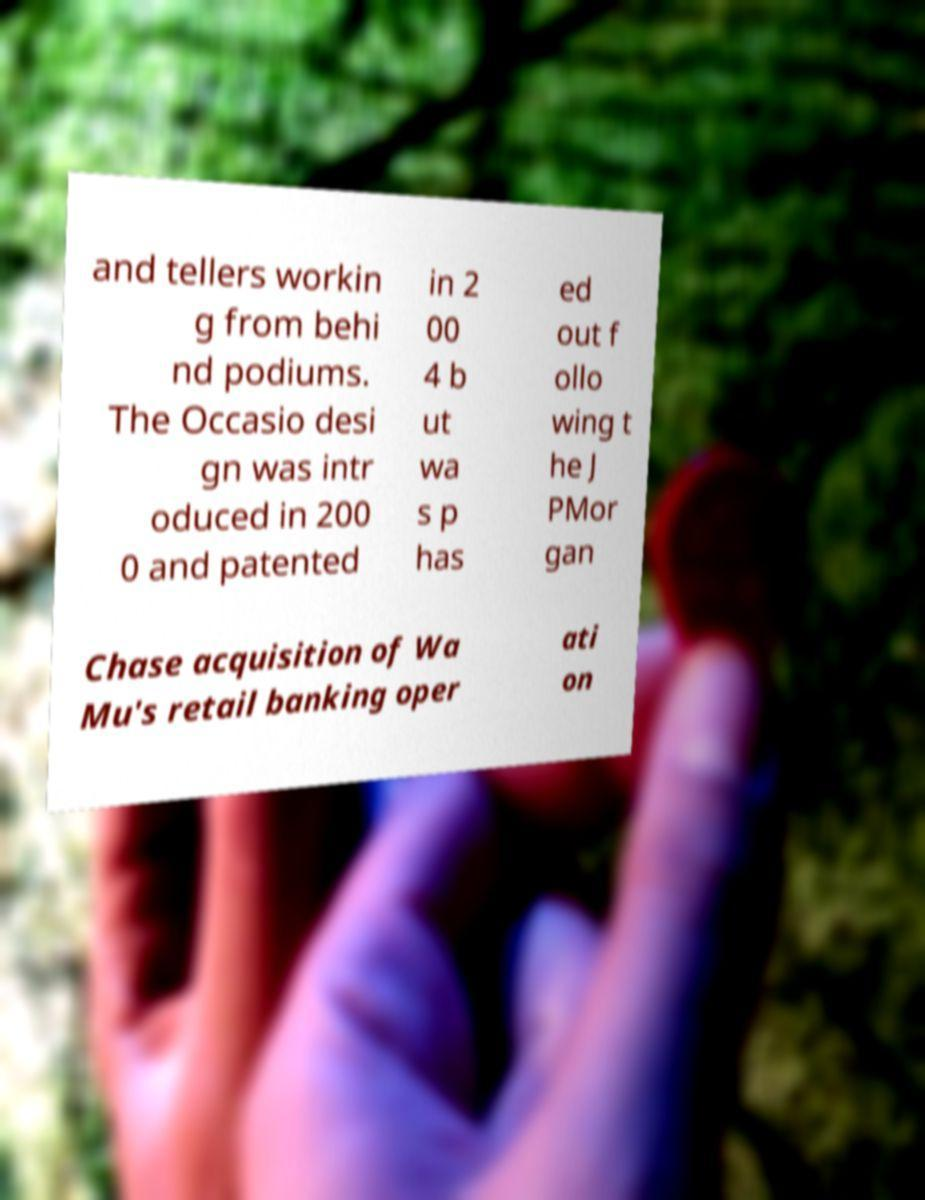What messages or text are displayed in this image? I need them in a readable, typed format. and tellers workin g from behi nd podiums. The Occasio desi gn was intr oduced in 200 0 and patented in 2 00 4 b ut wa s p has ed out f ollo wing t he J PMor gan Chase acquisition of Wa Mu's retail banking oper ati on 